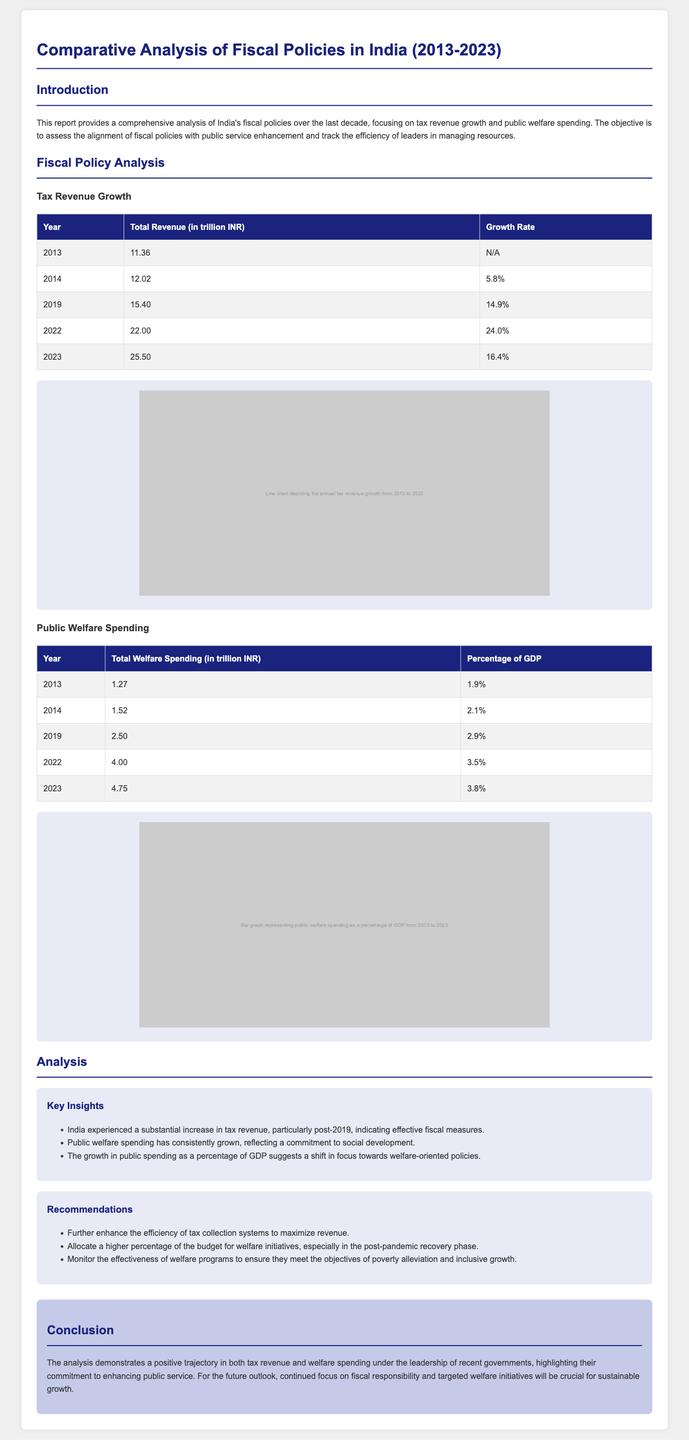What was the total tax revenue in 2022? The total tax revenue in 2022 is specified in the table as 22.00 trillion INR.
Answer: 22.00 trillion INR What was the growth rate of tax revenue in 2019? The growth rate for the year 2019 is given in the table as 14.9%.
Answer: 14.9% What is the total public welfare spending in 2023? The document provides the total welfare spending for 2023 as 4.75 trillion INR in the respective table.
Answer: 4.75 trillion INR What percentage of GDP was public welfare spending in 2022? The document states that public welfare spending as a percentage of GDP in 2022 was 3.5% in the table.
Answer: 3.5% Which year experienced a 24.0% growth rate in tax revenue? The growth rate of 24.0% for tax revenue is recorded for the year 2022 in the document.
Answer: 2022 What key insight indicates effective fiscal measures? The document mentions a substantial increase in tax revenue, particularly post-2019, as a key insight indicating effective fiscal measures.
Answer: Substantial increase in tax revenue What does the analysis recommend regarding tax collection systems? The recommendations section highlights the need to enhance the efficiency of tax collection systems to maximize revenue.
Answer: Enhance efficiency of tax collection systems What is the purpose of the report? The report assesses the alignment of fiscal policies with public service enhancement and tracks resource management efficacy by leaders.
Answer: Assess alignment of fiscal policies with public service enhancement Which color is used for the table headers? The table headers are given a background color of #1a237e, which is a shade of blue.
Answer: #1a237e 